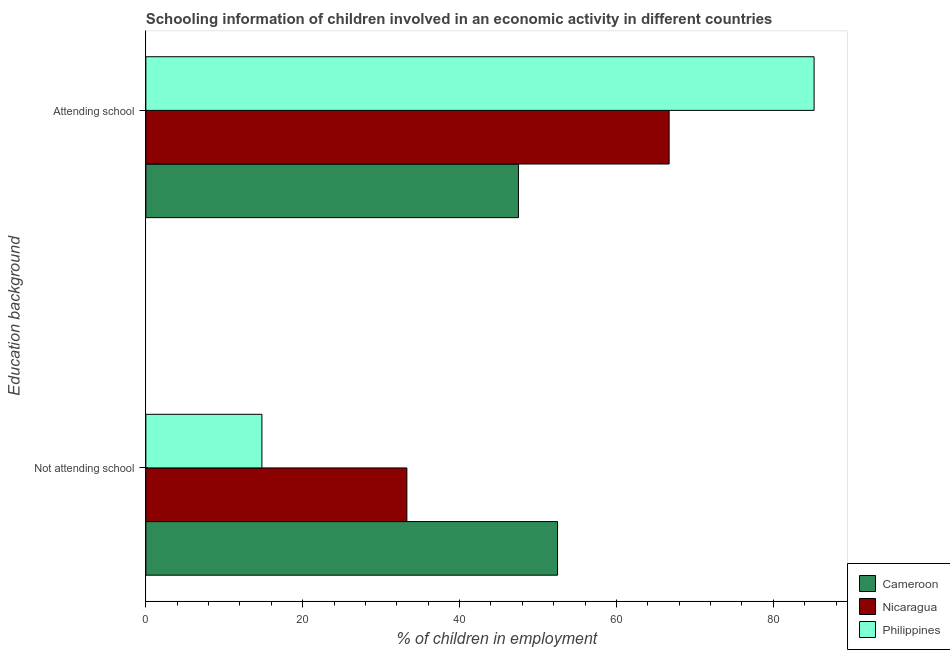How many groups of bars are there?
Your answer should be compact. 2. Are the number of bars per tick equal to the number of legend labels?
Ensure brevity in your answer.  Yes. How many bars are there on the 2nd tick from the top?
Your answer should be very brief. 3. What is the label of the 2nd group of bars from the top?
Ensure brevity in your answer.  Not attending school. What is the percentage of employed children who are not attending school in Nicaragua?
Offer a very short reply. 33.28. Across all countries, what is the maximum percentage of employed children who are not attending school?
Offer a terse response. 52.49. Across all countries, what is the minimum percentage of employed children who are not attending school?
Give a very brief answer. 14.8. In which country was the percentage of employed children who are attending school maximum?
Offer a very short reply. Philippines. In which country was the percentage of employed children who are attending school minimum?
Your response must be concise. Cameroon. What is the total percentage of employed children who are attending school in the graph?
Ensure brevity in your answer.  199.43. What is the difference between the percentage of employed children who are not attending school in Nicaragua and that in Cameroon?
Your answer should be very brief. -19.21. What is the difference between the percentage of employed children who are attending school in Philippines and the percentage of employed children who are not attending school in Cameroon?
Make the answer very short. 32.71. What is the average percentage of employed children who are not attending school per country?
Offer a very short reply. 33.52. What is the difference between the percentage of employed children who are not attending school and percentage of employed children who are attending school in Philippines?
Your answer should be very brief. -70.4. In how many countries, is the percentage of employed children who are attending school greater than 72 %?
Offer a very short reply. 1. What is the ratio of the percentage of employed children who are attending school in Cameroon to that in Philippines?
Ensure brevity in your answer.  0.56. What does the 2nd bar from the top in Not attending school represents?
Provide a succinct answer. Nicaragua. Are all the bars in the graph horizontal?
Make the answer very short. Yes. What is the difference between two consecutive major ticks on the X-axis?
Provide a succinct answer. 20. Are the values on the major ticks of X-axis written in scientific E-notation?
Offer a very short reply. No. Does the graph contain any zero values?
Your answer should be compact. No. Does the graph contain grids?
Provide a short and direct response. No. Where does the legend appear in the graph?
Offer a very short reply. Bottom right. How many legend labels are there?
Provide a short and direct response. 3. How are the legend labels stacked?
Give a very brief answer. Vertical. What is the title of the graph?
Keep it short and to the point. Schooling information of children involved in an economic activity in different countries. What is the label or title of the X-axis?
Provide a short and direct response. % of children in employment. What is the label or title of the Y-axis?
Provide a short and direct response. Education background. What is the % of children in employment of Cameroon in Not attending school?
Your answer should be very brief. 52.49. What is the % of children in employment in Nicaragua in Not attending school?
Keep it short and to the point. 33.28. What is the % of children in employment of Philippines in Not attending school?
Keep it short and to the point. 14.8. What is the % of children in employment of Cameroon in Attending school?
Provide a short and direct response. 47.51. What is the % of children in employment in Nicaragua in Attending school?
Offer a terse response. 66.72. What is the % of children in employment of Philippines in Attending school?
Keep it short and to the point. 85.2. Across all Education background, what is the maximum % of children in employment in Cameroon?
Ensure brevity in your answer.  52.49. Across all Education background, what is the maximum % of children in employment of Nicaragua?
Offer a very short reply. 66.72. Across all Education background, what is the maximum % of children in employment in Philippines?
Provide a succinct answer. 85.2. Across all Education background, what is the minimum % of children in employment in Cameroon?
Keep it short and to the point. 47.51. Across all Education background, what is the minimum % of children in employment of Nicaragua?
Ensure brevity in your answer.  33.28. Across all Education background, what is the minimum % of children in employment in Philippines?
Your answer should be compact. 14.8. What is the total % of children in employment of Cameroon in the graph?
Provide a short and direct response. 100. What is the difference between the % of children in employment in Cameroon in Not attending school and that in Attending school?
Offer a very short reply. 4.99. What is the difference between the % of children in employment in Nicaragua in Not attending school and that in Attending school?
Provide a short and direct response. -33.44. What is the difference between the % of children in employment in Philippines in Not attending school and that in Attending school?
Give a very brief answer. -70.4. What is the difference between the % of children in employment in Cameroon in Not attending school and the % of children in employment in Nicaragua in Attending school?
Your answer should be compact. -14.22. What is the difference between the % of children in employment of Cameroon in Not attending school and the % of children in employment of Philippines in Attending school?
Offer a terse response. -32.71. What is the difference between the % of children in employment in Nicaragua in Not attending school and the % of children in employment in Philippines in Attending school?
Offer a very short reply. -51.92. What is the average % of children in employment in Cameroon per Education background?
Your response must be concise. 50. What is the difference between the % of children in employment in Cameroon and % of children in employment in Nicaragua in Not attending school?
Provide a short and direct response. 19.21. What is the difference between the % of children in employment in Cameroon and % of children in employment in Philippines in Not attending school?
Keep it short and to the point. 37.7. What is the difference between the % of children in employment of Nicaragua and % of children in employment of Philippines in Not attending school?
Offer a very short reply. 18.48. What is the difference between the % of children in employment in Cameroon and % of children in employment in Nicaragua in Attending school?
Ensure brevity in your answer.  -19.21. What is the difference between the % of children in employment in Cameroon and % of children in employment in Philippines in Attending school?
Your answer should be very brief. -37.69. What is the difference between the % of children in employment in Nicaragua and % of children in employment in Philippines in Attending school?
Offer a very short reply. -18.48. What is the ratio of the % of children in employment of Cameroon in Not attending school to that in Attending school?
Offer a very short reply. 1.1. What is the ratio of the % of children in employment of Nicaragua in Not attending school to that in Attending school?
Provide a short and direct response. 0.5. What is the ratio of the % of children in employment in Philippines in Not attending school to that in Attending school?
Provide a short and direct response. 0.17. What is the difference between the highest and the second highest % of children in employment in Cameroon?
Offer a terse response. 4.99. What is the difference between the highest and the second highest % of children in employment in Nicaragua?
Keep it short and to the point. 33.44. What is the difference between the highest and the second highest % of children in employment of Philippines?
Offer a very short reply. 70.4. What is the difference between the highest and the lowest % of children in employment in Cameroon?
Your answer should be compact. 4.99. What is the difference between the highest and the lowest % of children in employment in Nicaragua?
Your response must be concise. 33.44. What is the difference between the highest and the lowest % of children in employment of Philippines?
Your response must be concise. 70.4. 